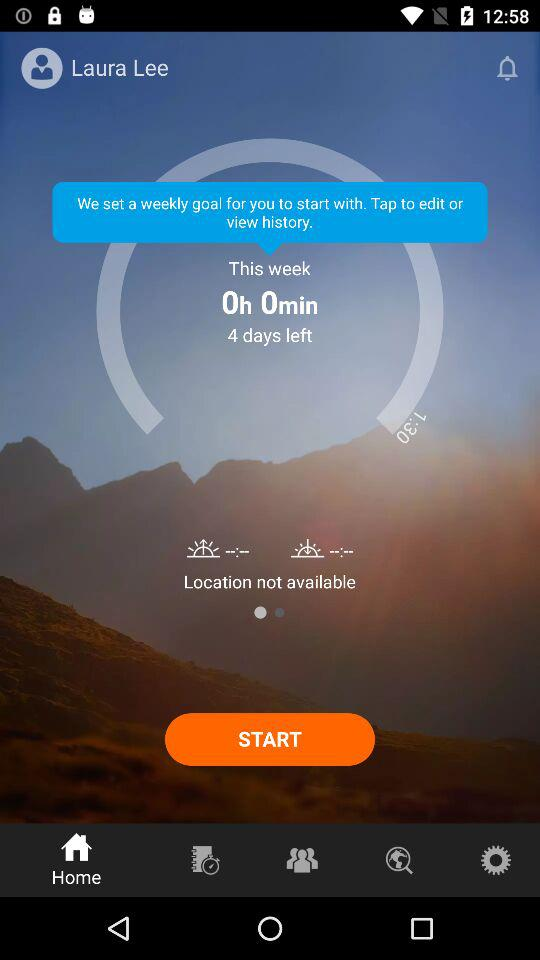What's the location status? The location is not available. 